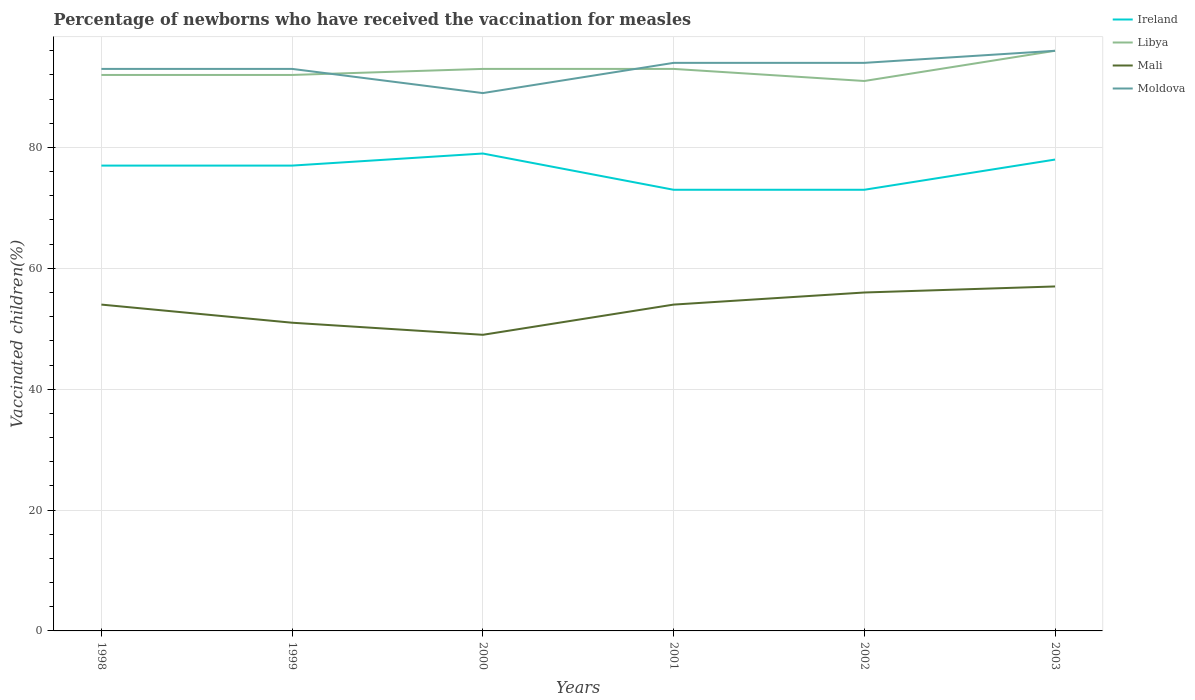Is the number of lines equal to the number of legend labels?
Provide a short and direct response. Yes. Across all years, what is the maximum percentage of vaccinated children in Libya?
Ensure brevity in your answer.  91. In which year was the percentage of vaccinated children in Moldova maximum?
Give a very brief answer. 2000. What is the total percentage of vaccinated children in Mali in the graph?
Keep it short and to the point. 0. What is the difference between the highest and the second highest percentage of vaccinated children in Libya?
Keep it short and to the point. 5. Is the percentage of vaccinated children in Libya strictly greater than the percentage of vaccinated children in Mali over the years?
Your response must be concise. No. Are the values on the major ticks of Y-axis written in scientific E-notation?
Make the answer very short. No. Does the graph contain any zero values?
Your answer should be very brief. No. Does the graph contain grids?
Provide a short and direct response. Yes. What is the title of the graph?
Ensure brevity in your answer.  Percentage of newborns who have received the vaccination for measles. What is the label or title of the X-axis?
Provide a succinct answer. Years. What is the label or title of the Y-axis?
Provide a succinct answer. Vaccinated children(%). What is the Vaccinated children(%) of Libya in 1998?
Your answer should be compact. 92. What is the Vaccinated children(%) of Moldova in 1998?
Your answer should be very brief. 93. What is the Vaccinated children(%) of Libya in 1999?
Provide a short and direct response. 92. What is the Vaccinated children(%) of Mali in 1999?
Keep it short and to the point. 51. What is the Vaccinated children(%) in Moldova in 1999?
Make the answer very short. 93. What is the Vaccinated children(%) in Ireland in 2000?
Offer a terse response. 79. What is the Vaccinated children(%) of Libya in 2000?
Ensure brevity in your answer.  93. What is the Vaccinated children(%) in Moldova in 2000?
Keep it short and to the point. 89. What is the Vaccinated children(%) in Ireland in 2001?
Give a very brief answer. 73. What is the Vaccinated children(%) in Libya in 2001?
Provide a short and direct response. 93. What is the Vaccinated children(%) in Moldova in 2001?
Your answer should be very brief. 94. What is the Vaccinated children(%) of Ireland in 2002?
Your response must be concise. 73. What is the Vaccinated children(%) of Libya in 2002?
Your response must be concise. 91. What is the Vaccinated children(%) in Moldova in 2002?
Provide a succinct answer. 94. What is the Vaccinated children(%) of Libya in 2003?
Provide a succinct answer. 96. What is the Vaccinated children(%) of Mali in 2003?
Offer a very short reply. 57. What is the Vaccinated children(%) in Moldova in 2003?
Make the answer very short. 96. Across all years, what is the maximum Vaccinated children(%) in Ireland?
Provide a short and direct response. 79. Across all years, what is the maximum Vaccinated children(%) of Libya?
Ensure brevity in your answer.  96. Across all years, what is the maximum Vaccinated children(%) in Moldova?
Give a very brief answer. 96. Across all years, what is the minimum Vaccinated children(%) in Libya?
Offer a terse response. 91. Across all years, what is the minimum Vaccinated children(%) of Moldova?
Provide a succinct answer. 89. What is the total Vaccinated children(%) of Ireland in the graph?
Provide a short and direct response. 457. What is the total Vaccinated children(%) of Libya in the graph?
Your answer should be very brief. 557. What is the total Vaccinated children(%) of Mali in the graph?
Ensure brevity in your answer.  321. What is the total Vaccinated children(%) in Moldova in the graph?
Provide a short and direct response. 559. What is the difference between the Vaccinated children(%) of Ireland in 1998 and that in 1999?
Offer a terse response. 0. What is the difference between the Vaccinated children(%) of Mali in 1998 and that in 1999?
Provide a short and direct response. 3. What is the difference between the Vaccinated children(%) of Mali in 1998 and that in 2000?
Ensure brevity in your answer.  5. What is the difference between the Vaccinated children(%) of Ireland in 1998 and that in 2001?
Keep it short and to the point. 4. What is the difference between the Vaccinated children(%) of Moldova in 1998 and that in 2001?
Offer a very short reply. -1. What is the difference between the Vaccinated children(%) in Libya in 1998 and that in 2002?
Ensure brevity in your answer.  1. What is the difference between the Vaccinated children(%) of Mali in 1998 and that in 2002?
Make the answer very short. -2. What is the difference between the Vaccinated children(%) in Moldova in 1998 and that in 2002?
Give a very brief answer. -1. What is the difference between the Vaccinated children(%) in Mali in 1998 and that in 2003?
Give a very brief answer. -3. What is the difference between the Vaccinated children(%) in Ireland in 1999 and that in 2000?
Offer a terse response. -2. What is the difference between the Vaccinated children(%) in Mali in 1999 and that in 2000?
Provide a short and direct response. 2. What is the difference between the Vaccinated children(%) in Libya in 1999 and that in 2001?
Give a very brief answer. -1. What is the difference between the Vaccinated children(%) of Ireland in 1999 and that in 2002?
Your answer should be compact. 4. What is the difference between the Vaccinated children(%) of Mali in 1999 and that in 2002?
Your response must be concise. -5. What is the difference between the Vaccinated children(%) in Moldova in 1999 and that in 2002?
Offer a terse response. -1. What is the difference between the Vaccinated children(%) of Libya in 1999 and that in 2003?
Keep it short and to the point. -4. What is the difference between the Vaccinated children(%) in Mali in 1999 and that in 2003?
Give a very brief answer. -6. What is the difference between the Vaccinated children(%) in Moldova in 1999 and that in 2003?
Your response must be concise. -3. What is the difference between the Vaccinated children(%) of Ireland in 2000 and that in 2001?
Ensure brevity in your answer.  6. What is the difference between the Vaccinated children(%) in Ireland in 2000 and that in 2002?
Your answer should be very brief. 6. What is the difference between the Vaccinated children(%) of Libya in 2000 and that in 2002?
Your answer should be compact. 2. What is the difference between the Vaccinated children(%) of Ireland in 2000 and that in 2003?
Your response must be concise. 1. What is the difference between the Vaccinated children(%) of Libya in 2000 and that in 2003?
Offer a terse response. -3. What is the difference between the Vaccinated children(%) in Moldova in 2000 and that in 2003?
Make the answer very short. -7. What is the difference between the Vaccinated children(%) in Libya in 2001 and that in 2002?
Provide a short and direct response. 2. What is the difference between the Vaccinated children(%) in Mali in 2001 and that in 2002?
Your answer should be compact. -2. What is the difference between the Vaccinated children(%) of Libya in 2001 and that in 2003?
Provide a succinct answer. -3. What is the difference between the Vaccinated children(%) in Mali in 2001 and that in 2003?
Keep it short and to the point. -3. What is the difference between the Vaccinated children(%) of Ireland in 2002 and that in 2003?
Keep it short and to the point. -5. What is the difference between the Vaccinated children(%) in Mali in 2002 and that in 2003?
Make the answer very short. -1. What is the difference between the Vaccinated children(%) in Ireland in 1998 and the Vaccinated children(%) in Libya in 1999?
Give a very brief answer. -15. What is the difference between the Vaccinated children(%) of Ireland in 1998 and the Vaccinated children(%) of Mali in 1999?
Make the answer very short. 26. What is the difference between the Vaccinated children(%) of Ireland in 1998 and the Vaccinated children(%) of Moldova in 1999?
Keep it short and to the point. -16. What is the difference between the Vaccinated children(%) of Libya in 1998 and the Vaccinated children(%) of Mali in 1999?
Make the answer very short. 41. What is the difference between the Vaccinated children(%) in Mali in 1998 and the Vaccinated children(%) in Moldova in 1999?
Provide a succinct answer. -39. What is the difference between the Vaccinated children(%) in Ireland in 1998 and the Vaccinated children(%) in Libya in 2000?
Keep it short and to the point. -16. What is the difference between the Vaccinated children(%) of Ireland in 1998 and the Vaccinated children(%) of Moldova in 2000?
Your answer should be compact. -12. What is the difference between the Vaccinated children(%) of Libya in 1998 and the Vaccinated children(%) of Mali in 2000?
Your response must be concise. 43. What is the difference between the Vaccinated children(%) of Libya in 1998 and the Vaccinated children(%) of Moldova in 2000?
Give a very brief answer. 3. What is the difference between the Vaccinated children(%) in Mali in 1998 and the Vaccinated children(%) in Moldova in 2000?
Give a very brief answer. -35. What is the difference between the Vaccinated children(%) in Ireland in 1998 and the Vaccinated children(%) in Libya in 2001?
Offer a terse response. -16. What is the difference between the Vaccinated children(%) of Ireland in 1998 and the Vaccinated children(%) of Moldova in 2001?
Your response must be concise. -17. What is the difference between the Vaccinated children(%) in Mali in 1998 and the Vaccinated children(%) in Moldova in 2001?
Ensure brevity in your answer.  -40. What is the difference between the Vaccinated children(%) of Ireland in 1998 and the Vaccinated children(%) of Libya in 2002?
Your answer should be compact. -14. What is the difference between the Vaccinated children(%) in Ireland in 1998 and the Vaccinated children(%) in Mali in 2002?
Offer a very short reply. 21. What is the difference between the Vaccinated children(%) in Libya in 1998 and the Vaccinated children(%) in Mali in 2002?
Offer a very short reply. 36. What is the difference between the Vaccinated children(%) of Libya in 1998 and the Vaccinated children(%) of Moldova in 2002?
Give a very brief answer. -2. What is the difference between the Vaccinated children(%) in Mali in 1998 and the Vaccinated children(%) in Moldova in 2002?
Your answer should be compact. -40. What is the difference between the Vaccinated children(%) in Ireland in 1998 and the Vaccinated children(%) in Libya in 2003?
Offer a terse response. -19. What is the difference between the Vaccinated children(%) in Libya in 1998 and the Vaccinated children(%) in Moldova in 2003?
Your response must be concise. -4. What is the difference between the Vaccinated children(%) in Mali in 1998 and the Vaccinated children(%) in Moldova in 2003?
Provide a short and direct response. -42. What is the difference between the Vaccinated children(%) in Ireland in 1999 and the Vaccinated children(%) in Mali in 2000?
Make the answer very short. 28. What is the difference between the Vaccinated children(%) in Ireland in 1999 and the Vaccinated children(%) in Moldova in 2000?
Keep it short and to the point. -12. What is the difference between the Vaccinated children(%) of Libya in 1999 and the Vaccinated children(%) of Mali in 2000?
Offer a terse response. 43. What is the difference between the Vaccinated children(%) of Mali in 1999 and the Vaccinated children(%) of Moldova in 2000?
Your answer should be compact. -38. What is the difference between the Vaccinated children(%) of Ireland in 1999 and the Vaccinated children(%) of Moldova in 2001?
Keep it short and to the point. -17. What is the difference between the Vaccinated children(%) in Libya in 1999 and the Vaccinated children(%) in Mali in 2001?
Your answer should be compact. 38. What is the difference between the Vaccinated children(%) in Libya in 1999 and the Vaccinated children(%) in Moldova in 2001?
Your answer should be compact. -2. What is the difference between the Vaccinated children(%) in Mali in 1999 and the Vaccinated children(%) in Moldova in 2001?
Your answer should be compact. -43. What is the difference between the Vaccinated children(%) in Ireland in 1999 and the Vaccinated children(%) in Libya in 2002?
Provide a succinct answer. -14. What is the difference between the Vaccinated children(%) of Ireland in 1999 and the Vaccinated children(%) of Mali in 2002?
Your answer should be compact. 21. What is the difference between the Vaccinated children(%) of Libya in 1999 and the Vaccinated children(%) of Mali in 2002?
Your response must be concise. 36. What is the difference between the Vaccinated children(%) of Libya in 1999 and the Vaccinated children(%) of Moldova in 2002?
Make the answer very short. -2. What is the difference between the Vaccinated children(%) in Mali in 1999 and the Vaccinated children(%) in Moldova in 2002?
Offer a terse response. -43. What is the difference between the Vaccinated children(%) in Ireland in 1999 and the Vaccinated children(%) in Moldova in 2003?
Offer a very short reply. -19. What is the difference between the Vaccinated children(%) of Libya in 1999 and the Vaccinated children(%) of Mali in 2003?
Give a very brief answer. 35. What is the difference between the Vaccinated children(%) in Libya in 1999 and the Vaccinated children(%) in Moldova in 2003?
Keep it short and to the point. -4. What is the difference between the Vaccinated children(%) in Mali in 1999 and the Vaccinated children(%) in Moldova in 2003?
Provide a short and direct response. -45. What is the difference between the Vaccinated children(%) of Ireland in 2000 and the Vaccinated children(%) of Mali in 2001?
Keep it short and to the point. 25. What is the difference between the Vaccinated children(%) of Ireland in 2000 and the Vaccinated children(%) of Moldova in 2001?
Provide a succinct answer. -15. What is the difference between the Vaccinated children(%) of Libya in 2000 and the Vaccinated children(%) of Mali in 2001?
Your response must be concise. 39. What is the difference between the Vaccinated children(%) in Libya in 2000 and the Vaccinated children(%) in Moldova in 2001?
Make the answer very short. -1. What is the difference between the Vaccinated children(%) of Mali in 2000 and the Vaccinated children(%) of Moldova in 2001?
Your answer should be very brief. -45. What is the difference between the Vaccinated children(%) in Ireland in 2000 and the Vaccinated children(%) in Libya in 2002?
Your response must be concise. -12. What is the difference between the Vaccinated children(%) in Mali in 2000 and the Vaccinated children(%) in Moldova in 2002?
Make the answer very short. -45. What is the difference between the Vaccinated children(%) of Ireland in 2000 and the Vaccinated children(%) of Mali in 2003?
Your response must be concise. 22. What is the difference between the Vaccinated children(%) of Ireland in 2000 and the Vaccinated children(%) of Moldova in 2003?
Give a very brief answer. -17. What is the difference between the Vaccinated children(%) of Libya in 2000 and the Vaccinated children(%) of Mali in 2003?
Make the answer very short. 36. What is the difference between the Vaccinated children(%) in Libya in 2000 and the Vaccinated children(%) in Moldova in 2003?
Make the answer very short. -3. What is the difference between the Vaccinated children(%) in Mali in 2000 and the Vaccinated children(%) in Moldova in 2003?
Provide a succinct answer. -47. What is the difference between the Vaccinated children(%) in Ireland in 2001 and the Vaccinated children(%) in Moldova in 2002?
Offer a terse response. -21. What is the difference between the Vaccinated children(%) of Libya in 2001 and the Vaccinated children(%) of Mali in 2002?
Offer a terse response. 37. What is the difference between the Vaccinated children(%) in Ireland in 2001 and the Vaccinated children(%) in Libya in 2003?
Keep it short and to the point. -23. What is the difference between the Vaccinated children(%) of Ireland in 2001 and the Vaccinated children(%) of Mali in 2003?
Your answer should be compact. 16. What is the difference between the Vaccinated children(%) of Ireland in 2001 and the Vaccinated children(%) of Moldova in 2003?
Offer a very short reply. -23. What is the difference between the Vaccinated children(%) of Libya in 2001 and the Vaccinated children(%) of Mali in 2003?
Provide a short and direct response. 36. What is the difference between the Vaccinated children(%) in Mali in 2001 and the Vaccinated children(%) in Moldova in 2003?
Ensure brevity in your answer.  -42. What is the difference between the Vaccinated children(%) in Ireland in 2002 and the Vaccinated children(%) in Libya in 2003?
Provide a succinct answer. -23. What is the difference between the Vaccinated children(%) in Ireland in 2002 and the Vaccinated children(%) in Moldova in 2003?
Your response must be concise. -23. What is the difference between the Vaccinated children(%) of Mali in 2002 and the Vaccinated children(%) of Moldova in 2003?
Offer a terse response. -40. What is the average Vaccinated children(%) of Ireland per year?
Offer a terse response. 76.17. What is the average Vaccinated children(%) in Libya per year?
Offer a terse response. 92.83. What is the average Vaccinated children(%) of Mali per year?
Give a very brief answer. 53.5. What is the average Vaccinated children(%) in Moldova per year?
Make the answer very short. 93.17. In the year 1998, what is the difference between the Vaccinated children(%) in Ireland and Vaccinated children(%) in Libya?
Provide a succinct answer. -15. In the year 1998, what is the difference between the Vaccinated children(%) of Ireland and Vaccinated children(%) of Moldova?
Provide a succinct answer. -16. In the year 1998, what is the difference between the Vaccinated children(%) in Libya and Vaccinated children(%) in Moldova?
Ensure brevity in your answer.  -1. In the year 1998, what is the difference between the Vaccinated children(%) in Mali and Vaccinated children(%) in Moldova?
Your answer should be compact. -39. In the year 1999, what is the difference between the Vaccinated children(%) of Ireland and Vaccinated children(%) of Libya?
Provide a succinct answer. -15. In the year 1999, what is the difference between the Vaccinated children(%) of Ireland and Vaccinated children(%) of Mali?
Provide a short and direct response. 26. In the year 1999, what is the difference between the Vaccinated children(%) in Libya and Vaccinated children(%) in Mali?
Your answer should be very brief. 41. In the year 1999, what is the difference between the Vaccinated children(%) in Libya and Vaccinated children(%) in Moldova?
Ensure brevity in your answer.  -1. In the year 1999, what is the difference between the Vaccinated children(%) in Mali and Vaccinated children(%) in Moldova?
Your answer should be very brief. -42. In the year 2000, what is the difference between the Vaccinated children(%) of Ireland and Vaccinated children(%) of Mali?
Your answer should be very brief. 30. In the year 2000, what is the difference between the Vaccinated children(%) in Libya and Vaccinated children(%) in Mali?
Offer a terse response. 44. In the year 2000, what is the difference between the Vaccinated children(%) in Libya and Vaccinated children(%) in Moldova?
Your answer should be compact. 4. In the year 2000, what is the difference between the Vaccinated children(%) of Mali and Vaccinated children(%) of Moldova?
Provide a succinct answer. -40. In the year 2001, what is the difference between the Vaccinated children(%) in Ireland and Vaccinated children(%) in Libya?
Your response must be concise. -20. In the year 2001, what is the difference between the Vaccinated children(%) of Ireland and Vaccinated children(%) of Mali?
Offer a terse response. 19. In the year 2001, what is the difference between the Vaccinated children(%) of Ireland and Vaccinated children(%) of Moldova?
Your response must be concise. -21. In the year 2001, what is the difference between the Vaccinated children(%) in Libya and Vaccinated children(%) in Moldova?
Your response must be concise. -1. In the year 2002, what is the difference between the Vaccinated children(%) of Ireland and Vaccinated children(%) of Libya?
Offer a very short reply. -18. In the year 2002, what is the difference between the Vaccinated children(%) in Ireland and Vaccinated children(%) in Mali?
Make the answer very short. 17. In the year 2002, what is the difference between the Vaccinated children(%) of Libya and Vaccinated children(%) of Mali?
Your response must be concise. 35. In the year 2002, what is the difference between the Vaccinated children(%) in Libya and Vaccinated children(%) in Moldova?
Ensure brevity in your answer.  -3. In the year 2002, what is the difference between the Vaccinated children(%) of Mali and Vaccinated children(%) of Moldova?
Make the answer very short. -38. In the year 2003, what is the difference between the Vaccinated children(%) of Ireland and Vaccinated children(%) of Libya?
Offer a terse response. -18. In the year 2003, what is the difference between the Vaccinated children(%) of Ireland and Vaccinated children(%) of Mali?
Make the answer very short. 21. In the year 2003, what is the difference between the Vaccinated children(%) of Libya and Vaccinated children(%) of Moldova?
Provide a short and direct response. 0. In the year 2003, what is the difference between the Vaccinated children(%) of Mali and Vaccinated children(%) of Moldova?
Your answer should be compact. -39. What is the ratio of the Vaccinated children(%) in Mali in 1998 to that in 1999?
Keep it short and to the point. 1.06. What is the ratio of the Vaccinated children(%) of Ireland in 1998 to that in 2000?
Ensure brevity in your answer.  0.97. What is the ratio of the Vaccinated children(%) of Mali in 1998 to that in 2000?
Offer a very short reply. 1.1. What is the ratio of the Vaccinated children(%) in Moldova in 1998 to that in 2000?
Offer a terse response. 1.04. What is the ratio of the Vaccinated children(%) in Ireland in 1998 to that in 2001?
Provide a succinct answer. 1.05. What is the ratio of the Vaccinated children(%) in Libya in 1998 to that in 2001?
Make the answer very short. 0.99. What is the ratio of the Vaccinated children(%) of Mali in 1998 to that in 2001?
Provide a succinct answer. 1. What is the ratio of the Vaccinated children(%) of Moldova in 1998 to that in 2001?
Provide a short and direct response. 0.99. What is the ratio of the Vaccinated children(%) of Ireland in 1998 to that in 2002?
Your answer should be very brief. 1.05. What is the ratio of the Vaccinated children(%) of Libya in 1998 to that in 2002?
Give a very brief answer. 1.01. What is the ratio of the Vaccinated children(%) in Ireland in 1998 to that in 2003?
Keep it short and to the point. 0.99. What is the ratio of the Vaccinated children(%) in Mali in 1998 to that in 2003?
Provide a succinct answer. 0.95. What is the ratio of the Vaccinated children(%) of Moldova in 1998 to that in 2003?
Your answer should be compact. 0.97. What is the ratio of the Vaccinated children(%) of Ireland in 1999 to that in 2000?
Your answer should be compact. 0.97. What is the ratio of the Vaccinated children(%) of Libya in 1999 to that in 2000?
Keep it short and to the point. 0.99. What is the ratio of the Vaccinated children(%) of Mali in 1999 to that in 2000?
Your answer should be very brief. 1.04. What is the ratio of the Vaccinated children(%) in Moldova in 1999 to that in 2000?
Make the answer very short. 1.04. What is the ratio of the Vaccinated children(%) of Ireland in 1999 to that in 2001?
Give a very brief answer. 1.05. What is the ratio of the Vaccinated children(%) of Mali in 1999 to that in 2001?
Give a very brief answer. 0.94. What is the ratio of the Vaccinated children(%) of Moldova in 1999 to that in 2001?
Keep it short and to the point. 0.99. What is the ratio of the Vaccinated children(%) in Ireland in 1999 to that in 2002?
Keep it short and to the point. 1.05. What is the ratio of the Vaccinated children(%) in Mali in 1999 to that in 2002?
Keep it short and to the point. 0.91. What is the ratio of the Vaccinated children(%) of Ireland in 1999 to that in 2003?
Your answer should be compact. 0.99. What is the ratio of the Vaccinated children(%) in Libya in 1999 to that in 2003?
Give a very brief answer. 0.96. What is the ratio of the Vaccinated children(%) of Mali in 1999 to that in 2003?
Offer a terse response. 0.89. What is the ratio of the Vaccinated children(%) in Moldova in 1999 to that in 2003?
Provide a short and direct response. 0.97. What is the ratio of the Vaccinated children(%) in Ireland in 2000 to that in 2001?
Offer a terse response. 1.08. What is the ratio of the Vaccinated children(%) in Mali in 2000 to that in 2001?
Give a very brief answer. 0.91. What is the ratio of the Vaccinated children(%) in Moldova in 2000 to that in 2001?
Your answer should be very brief. 0.95. What is the ratio of the Vaccinated children(%) of Ireland in 2000 to that in 2002?
Your response must be concise. 1.08. What is the ratio of the Vaccinated children(%) of Libya in 2000 to that in 2002?
Provide a succinct answer. 1.02. What is the ratio of the Vaccinated children(%) in Mali in 2000 to that in 2002?
Offer a very short reply. 0.88. What is the ratio of the Vaccinated children(%) of Moldova in 2000 to that in 2002?
Your response must be concise. 0.95. What is the ratio of the Vaccinated children(%) in Ireland in 2000 to that in 2003?
Give a very brief answer. 1.01. What is the ratio of the Vaccinated children(%) in Libya in 2000 to that in 2003?
Offer a very short reply. 0.97. What is the ratio of the Vaccinated children(%) of Mali in 2000 to that in 2003?
Your answer should be very brief. 0.86. What is the ratio of the Vaccinated children(%) in Moldova in 2000 to that in 2003?
Keep it short and to the point. 0.93. What is the ratio of the Vaccinated children(%) of Libya in 2001 to that in 2002?
Keep it short and to the point. 1.02. What is the ratio of the Vaccinated children(%) in Mali in 2001 to that in 2002?
Offer a very short reply. 0.96. What is the ratio of the Vaccinated children(%) in Ireland in 2001 to that in 2003?
Your answer should be compact. 0.94. What is the ratio of the Vaccinated children(%) in Libya in 2001 to that in 2003?
Offer a terse response. 0.97. What is the ratio of the Vaccinated children(%) of Moldova in 2001 to that in 2003?
Your answer should be very brief. 0.98. What is the ratio of the Vaccinated children(%) of Ireland in 2002 to that in 2003?
Provide a short and direct response. 0.94. What is the ratio of the Vaccinated children(%) of Libya in 2002 to that in 2003?
Ensure brevity in your answer.  0.95. What is the ratio of the Vaccinated children(%) in Mali in 2002 to that in 2003?
Your answer should be compact. 0.98. What is the ratio of the Vaccinated children(%) in Moldova in 2002 to that in 2003?
Your answer should be compact. 0.98. What is the difference between the highest and the second highest Vaccinated children(%) in Ireland?
Ensure brevity in your answer.  1. What is the difference between the highest and the second highest Vaccinated children(%) in Libya?
Make the answer very short. 3. What is the difference between the highest and the second highest Vaccinated children(%) of Mali?
Your answer should be compact. 1. What is the difference between the highest and the lowest Vaccinated children(%) of Ireland?
Your response must be concise. 6. What is the difference between the highest and the lowest Vaccinated children(%) of Libya?
Give a very brief answer. 5. 